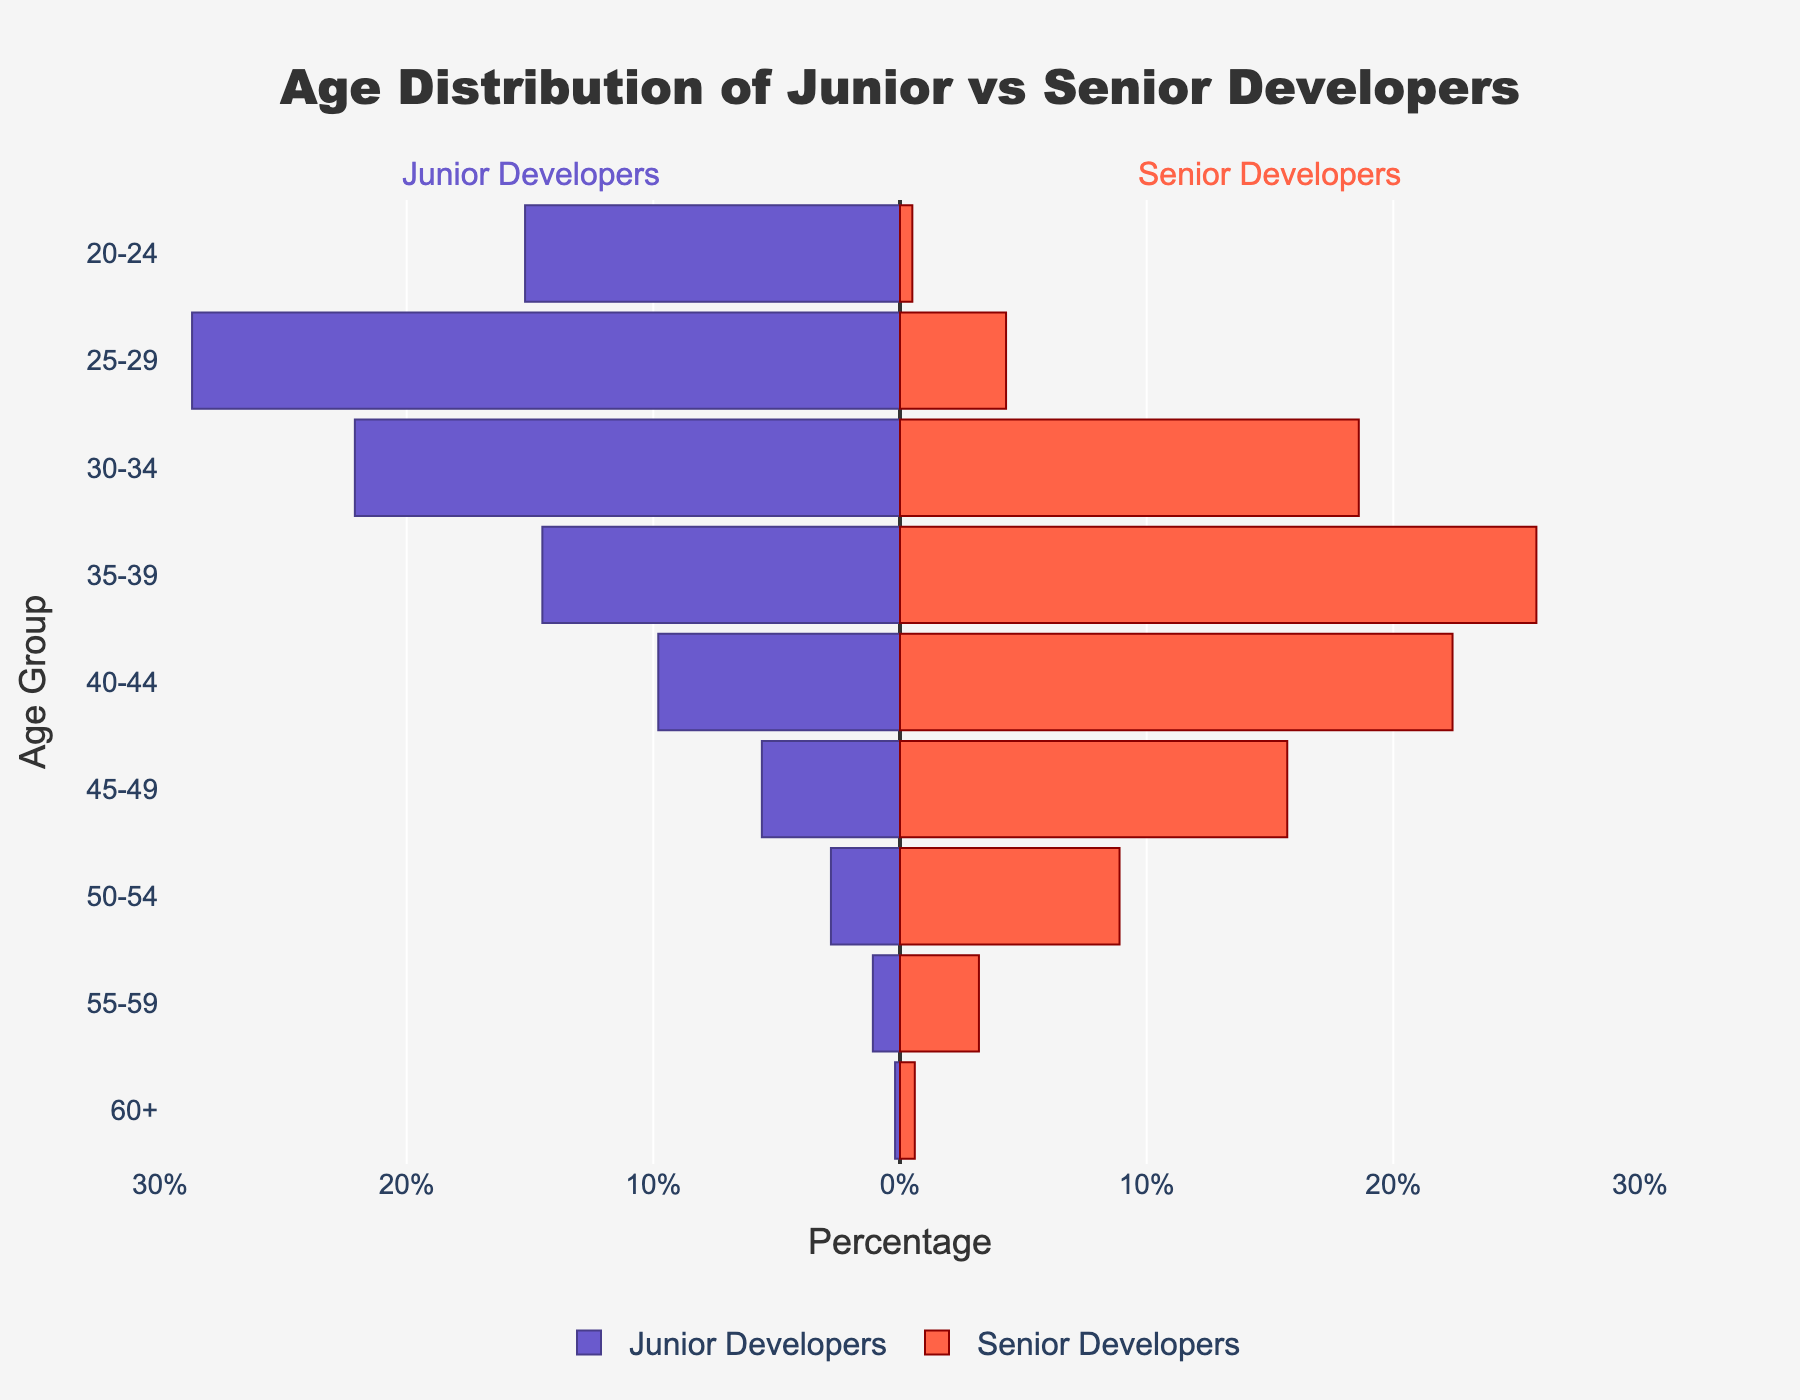What's the title of the figure? The title is located at the top center of the figure. It reads "Age Distribution of Junior vs Senior Developers".
Answer: Age Distribution of Junior vs Senior Developers How many age groups are displayed in the figure? Look at the y-axis, which represents age groups. Count the number of age groups listed.
Answer: 9 In which age group do junior developers have the highest percentage? Look at the bar lengths on the left side (negative values) and find the age group with the longest bar.
Answer: 25-29 By how many percentage points do senior developers in the 50-54 age group surpass junior developers? Find the bars for the 50-54 age group and measure the difference between the values for senior and junior developers. Senior values for 50-54 is 8.9%, and junior values is 2.8%. The difference is 8.9% - 2.8%.
Answer: 6.1% Which age group has the closest percentages between junior and senior developers? Compare the differences for each age group. For the 30-34 age group, the percentages are 22.1% for junior developers and 18.6% for senior developers, with a difference of 3.5%. This difference is the smallest among all age groups.
Answer: 30-34 At what age group do senior developers start having a higher percentage than junior developers? Look at the crossover point where the right bars (senior developers) start being longer than the left bars (junior developers). This happens at the 35-39 age group.
Answer: 35-39 What's the combined percentage of junior and senior developers in the 40-44 age group? Sum the percentages for junior and senior developers in the 40-44 age group. Junior is 9.8%, and senior is 22.4%. The combined percentage is 9.8% + 22.4%.
Answer: 32.2% How does the percentage of senior developers aged 45-49 compare to junior developers aged 25-29? Compare the heights of the corresponding bars. Senior developers aged 45-49 represent 15.7%, while junior developers aged 25-29 represent 28.7%.
Answer: 15.7% vs 28.7% Which age group has the lowest percentage of senior developers? Identify the smallest bar on the right side (positive values). This occurs in the 60+ age group, with 0.6%.
Answer: 60+ How does the number of age groups with decreasing percentages for junior developers compare to the number for senior developers? Count the age groups from youngest to oldest and observe the trend. For junior developers, the percentages consistently decrease from the 20-24 to the 60+ age group. For senior developers, they increase from 20-24 to 35-39, then decrease.
Answer: 9 decreasing for juniors, 5 increasing and 4 decreasing for seniors 